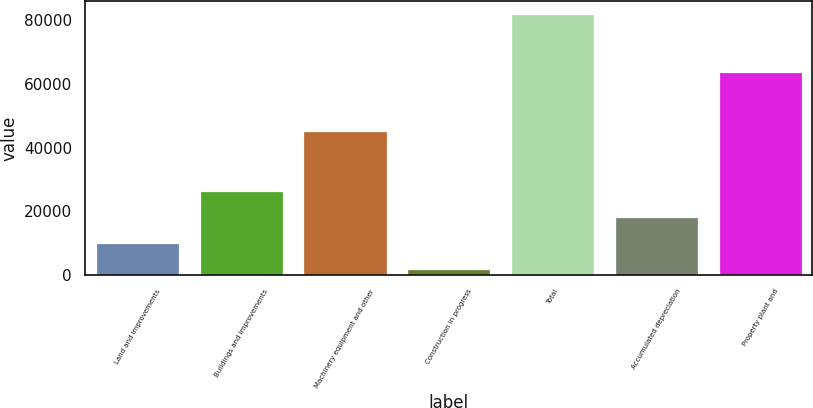<chart> <loc_0><loc_0><loc_500><loc_500><bar_chart><fcel>Land and improvements<fcel>Buildings and improvements<fcel>Machinery equipment and other<fcel>Construction in progress<fcel>Total<fcel>Accumulated depreciation<fcel>Property plant and<nl><fcel>9891.4<fcel>26271.4<fcel>45283<fcel>1891<fcel>81895<fcel>18271<fcel>63624<nl></chart> 